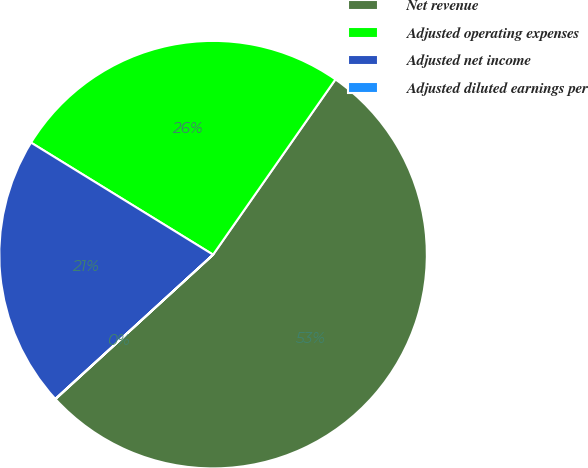Convert chart. <chart><loc_0><loc_0><loc_500><loc_500><pie_chart><fcel>Net revenue<fcel>Adjusted operating expenses<fcel>Adjusted net income<fcel>Adjusted diluted earnings per<nl><fcel>53.49%<fcel>25.92%<fcel>20.57%<fcel>0.02%<nl></chart> 